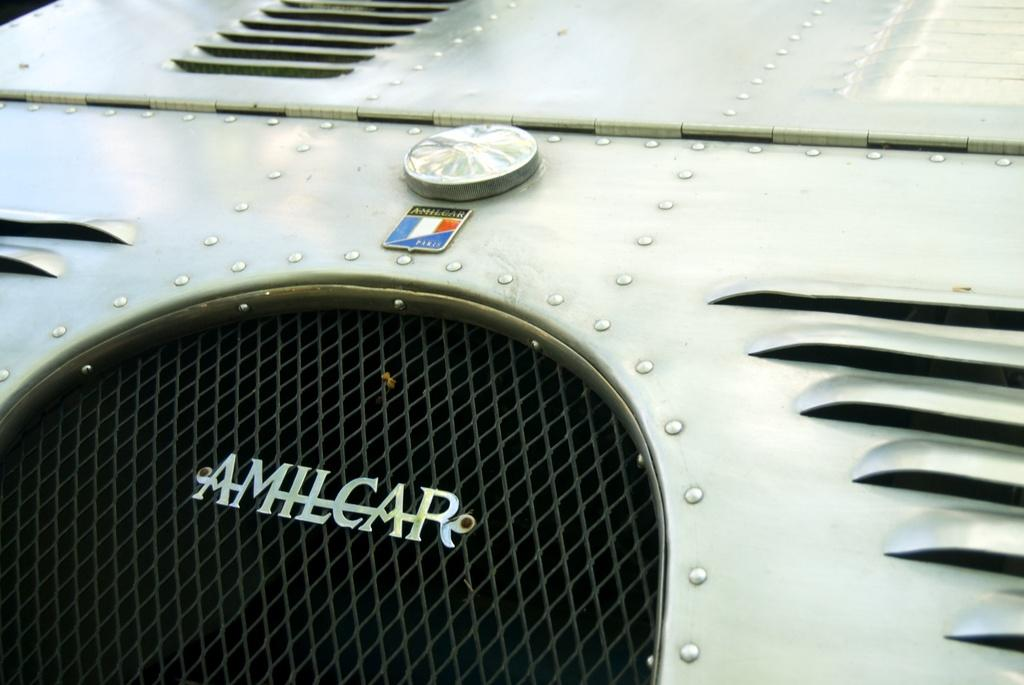What is the main subject of the image? The main subject of the image is a car. Can you describe any specific details about the car? The image is a zoomed-in view of the car, so we can see the car logo in the middle of the image. Is there any text present in the image? Yes, there is text written at the bottom of the image. What type of hat is the car wearing in the image? There is no hat present in the image; it is a car, not a person. Can you tell me how many pages of prose are visible in the image? There is no prose present in the image; it is a car with a logo and text at the bottom. 